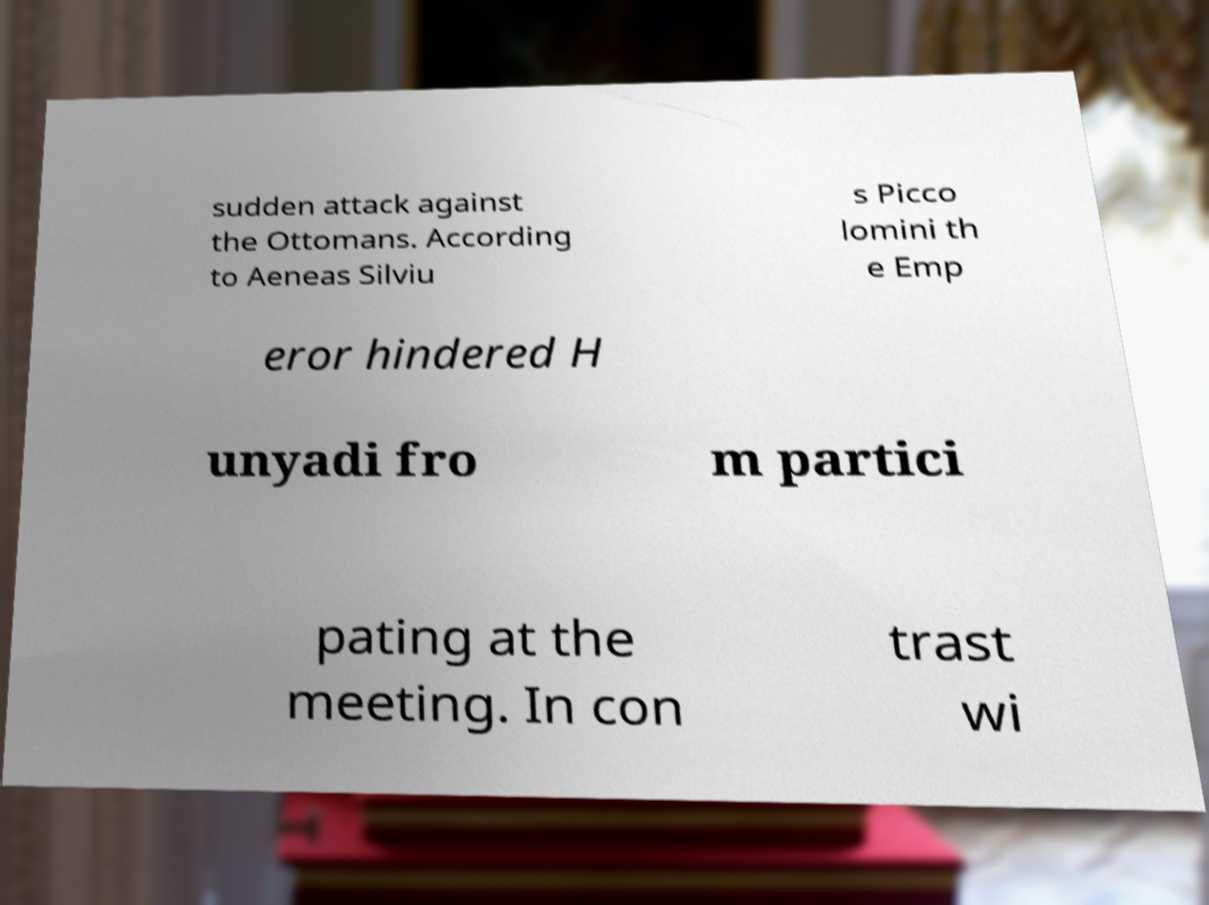Please identify and transcribe the text found in this image. sudden attack against the Ottomans. According to Aeneas Silviu s Picco lomini th e Emp eror hindered H unyadi fro m partici pating at the meeting. In con trast wi 